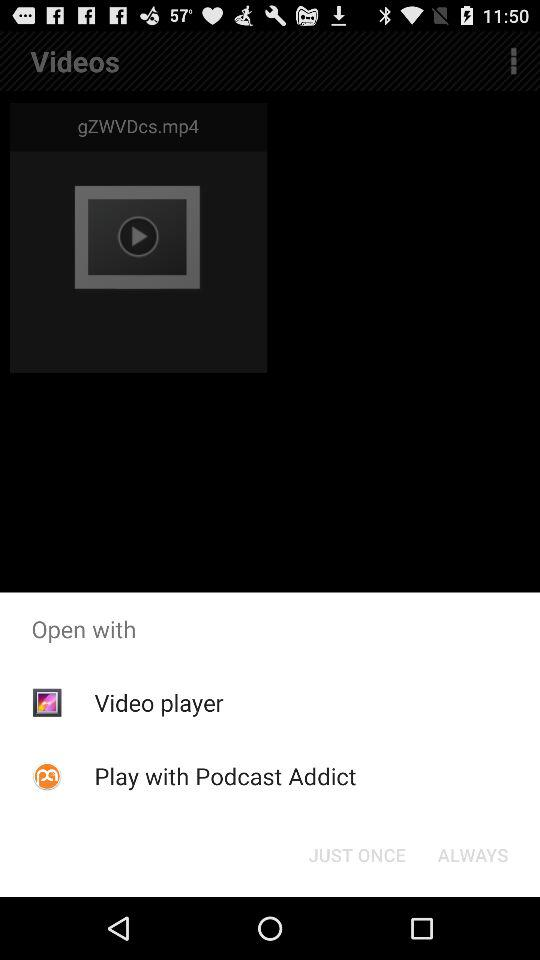How long is "gZWVDcs.mp4"?
When the provided information is insufficient, respond with <no answer>. <no answer> 